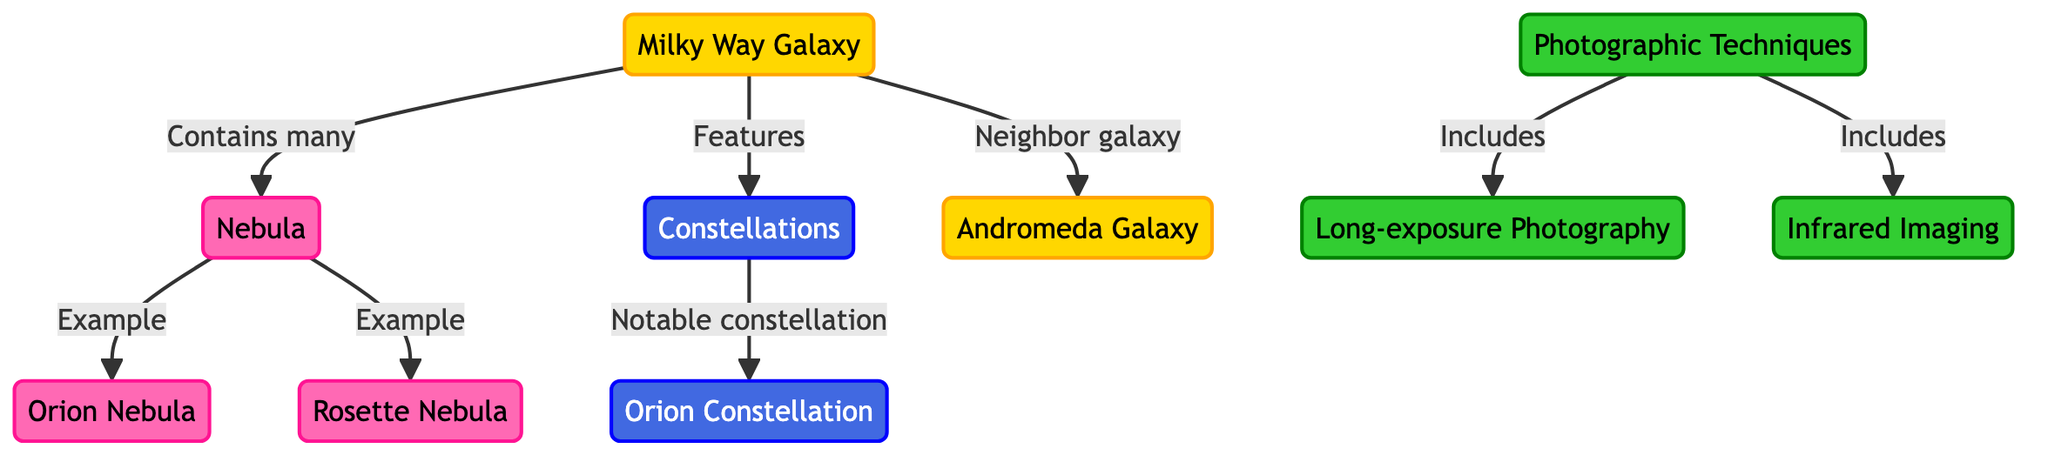What galaxy is represented in the diagram? The diagram shows the Milky Way Galaxy at the top, which is the primary reference point for the other elements.
Answer: Milky Way Galaxy How many nebula examples are listed in the diagram? There are two examples of nebulae mentioned in the diagram: the Orion Nebula and the Rosette Nebula. Therefore, the count is derived from identifying these two linked nodes under the nebula category.
Answer: 2 Which galaxy is referred to as the Milky Way's neighbor? The Andromeda Galaxy is identified as the neighboring galaxy to the Milky Way in the diagram, reflecting the relationship between these two significant galaxies.
Answer: Andromeda Galaxy What type of photography technique is included in the diagram? The diagram lists two photographic techniques: Long-exposure Photography and Infrared Imaging. Thus, the first technique mentioned in the flow is the answer.
Answer: Long-exposure Photography What is one notable constellation shown in the diagram? The diagram highlights Orion as a notable constellation linked to the broader category of constellations. It is the only constellation explicitly mentioned in the diagram.
Answer: Orion How many techniques for photography are detailed in the diagram? Two techniques for photography are indicated: Long-exposure Photography and Infrared Imaging. This conclusion is obtained by counting the techniques listed under the Photographic Techniques node.
Answer: 2 What type of astronomical object is the Rosette Nebula? The Rosette Nebula, as indicated in the diagram, is classified as a nebula, which is a type of interstellar cloud, specifically mentioned in the context of examples under the broader category of nebulae.
Answer: Nebula Which object is categorized under "constellation"? Orion is specifically mentioned under the constellation category in the diagram, indicating that it is an example of a constellation in the Milky Way region.
Answer: Orion What color is used to depict the galaxy in the diagram? In the diagram, the Milky Way Galaxy is represented using the color gold, specifically defined by the fill color #FFD700. This can be observed from the class definitions applied to the galaxy node.
Answer: Gold 